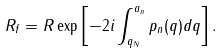Convert formula to latex. <formula><loc_0><loc_0><loc_500><loc_500>R _ { f } = R \exp \left [ - 2 i \int _ { q _ { N } } ^ { a _ { n } } p _ { n } ( q ) d q \right ] .</formula> 